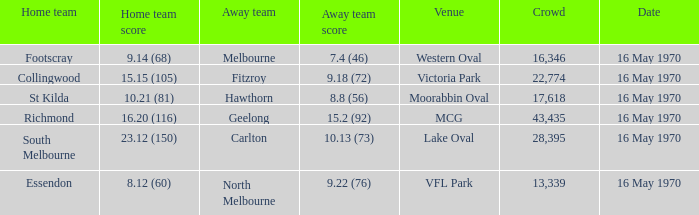What away team scored 9.18 (72)? Fitzroy. 